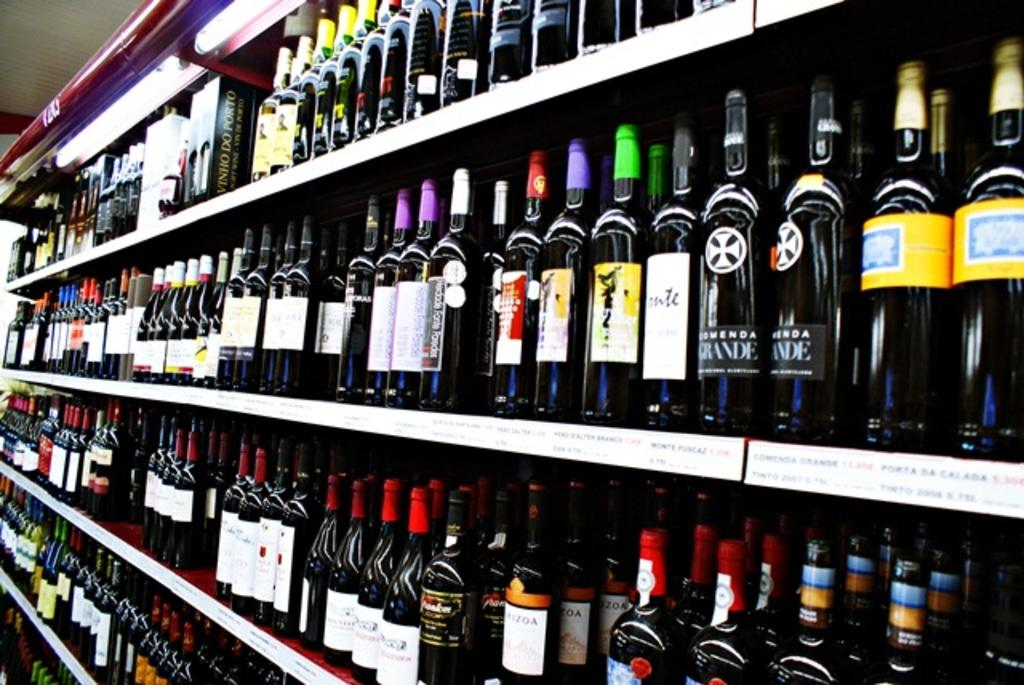Provide a one-sentence caption for the provided image. Stocked shelves of bottled alcoholic drinks, in various sizes and brands. 